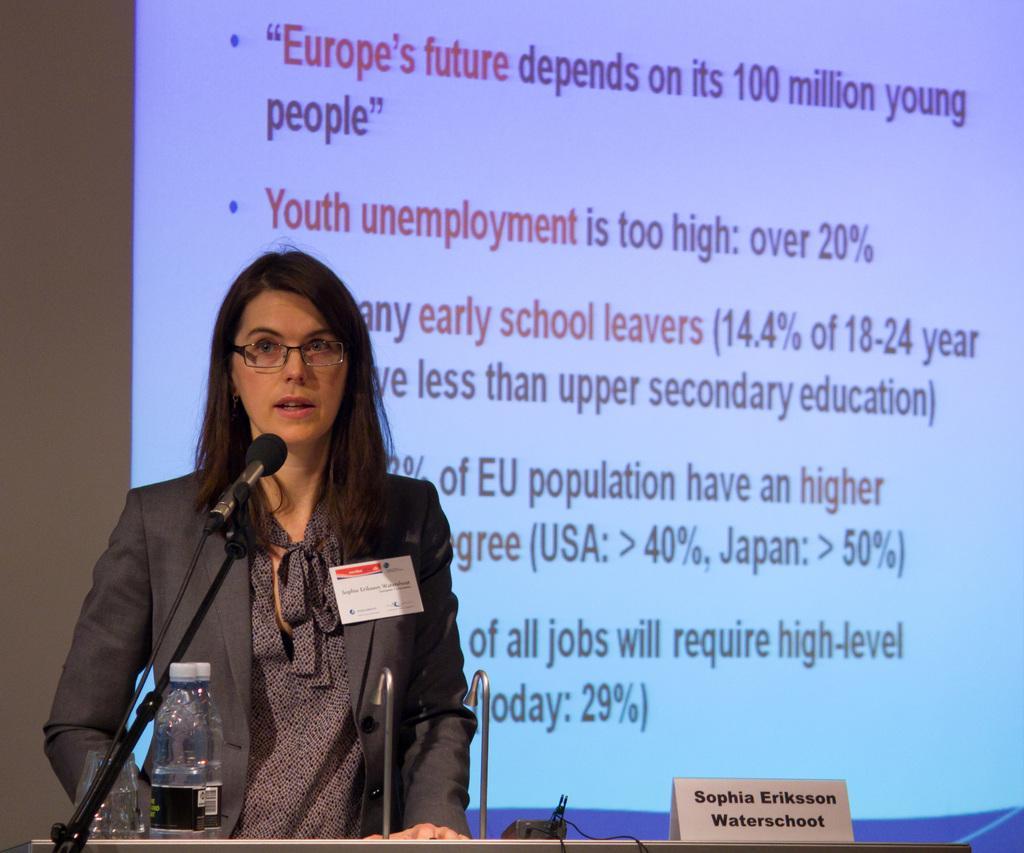Could you give a brief overview of what you see in this image? In this picture we can see a woman with a tag and spectacles. In front of the woman, it looks like a podium and on the podium, there are cables, a name plate, bottle, microphone and some objects. Behind the woman, there is a projector screen. 